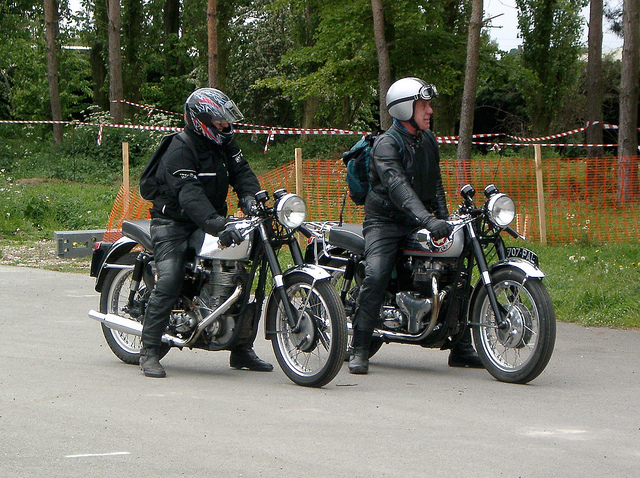Extract all visible text content from this image. 707 PAL 